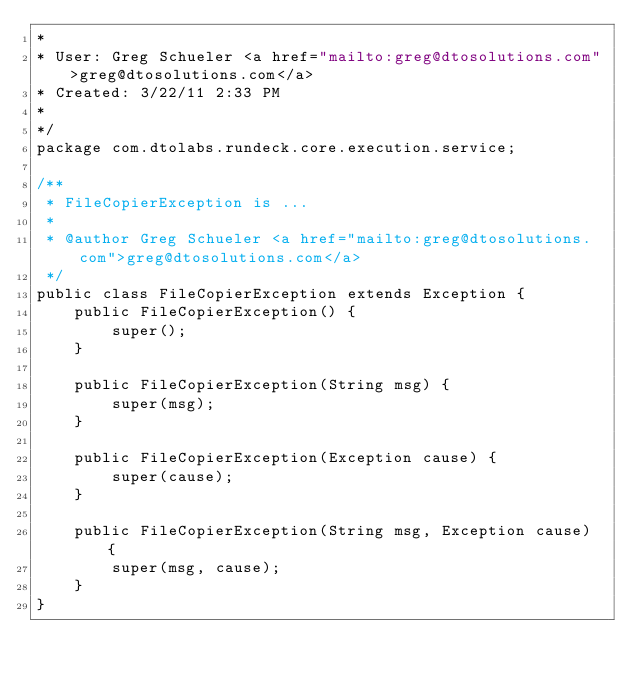Convert code to text. <code><loc_0><loc_0><loc_500><loc_500><_Java_>* 
* User: Greg Schueler <a href="mailto:greg@dtosolutions.com">greg@dtosolutions.com</a>
* Created: 3/22/11 2:33 PM
* 
*/
package com.dtolabs.rundeck.core.execution.service;

/**
 * FileCopierException is ...
 *
 * @author Greg Schueler <a href="mailto:greg@dtosolutions.com">greg@dtosolutions.com</a>
 */
public class FileCopierException extends Exception {
    public FileCopierException() {
        super();
    }

    public FileCopierException(String msg) {
        super(msg);
    }

    public FileCopierException(Exception cause) {
        super(cause);
    }

    public FileCopierException(String msg, Exception cause) {
        super(msg, cause);
    }
}
</code> 